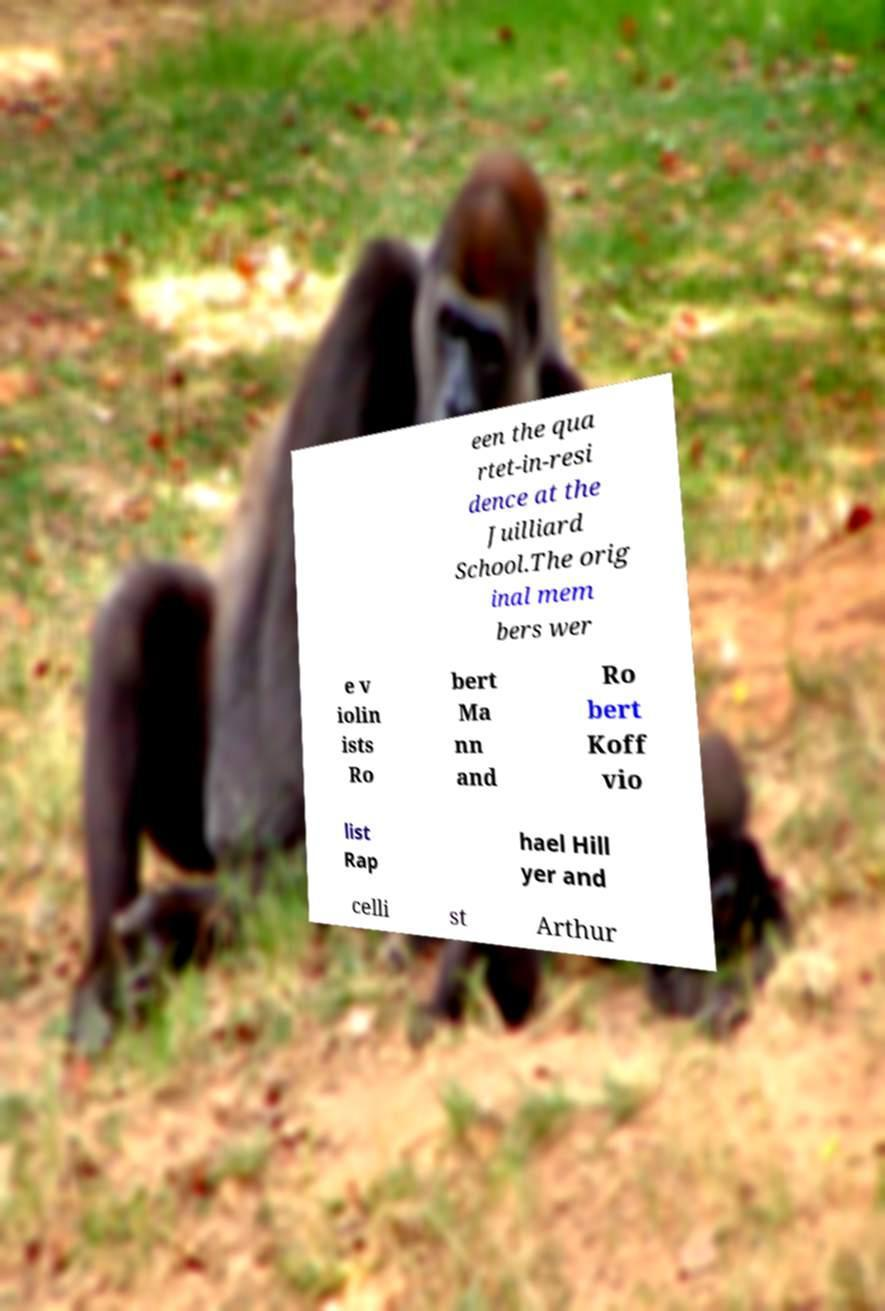Please identify and transcribe the text found in this image. een the qua rtet-in-resi dence at the Juilliard School.The orig inal mem bers wer e v iolin ists Ro bert Ma nn and Ro bert Koff vio list Rap hael Hill yer and celli st Arthur 